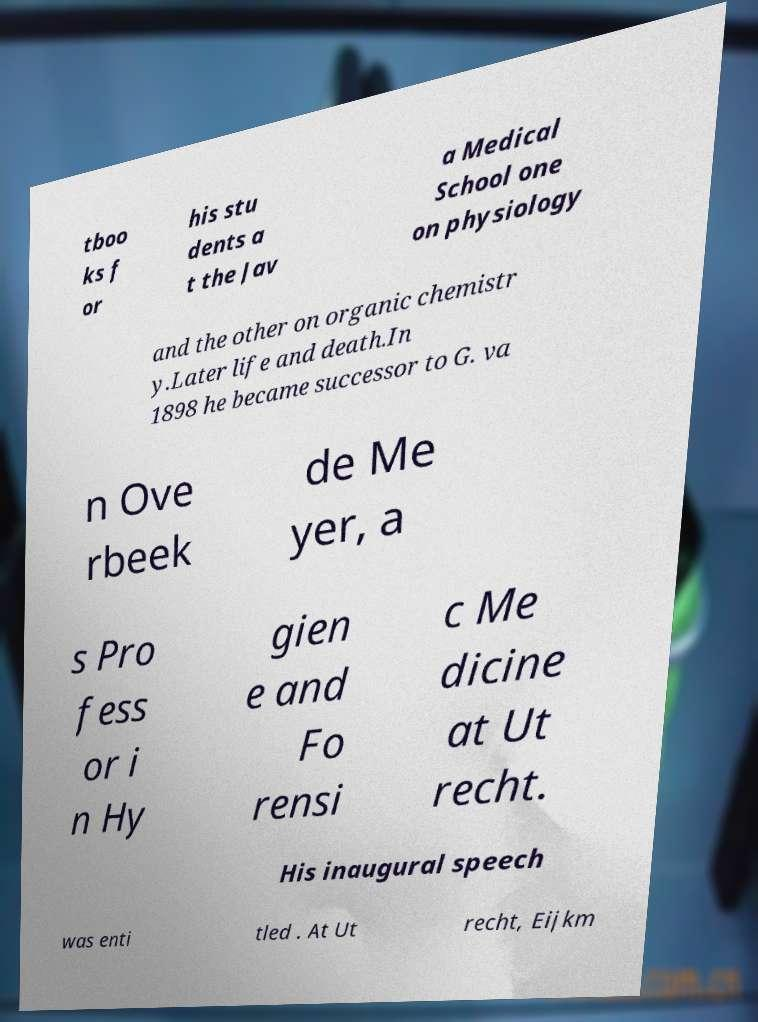Please read and relay the text visible in this image. What does it say? tboo ks f or his stu dents a t the Jav a Medical School one on physiology and the other on organic chemistr y.Later life and death.In 1898 he became successor to G. va n Ove rbeek de Me yer, a s Pro fess or i n Hy gien e and Fo rensi c Me dicine at Ut recht. His inaugural speech was enti tled . At Ut recht, Eijkm 